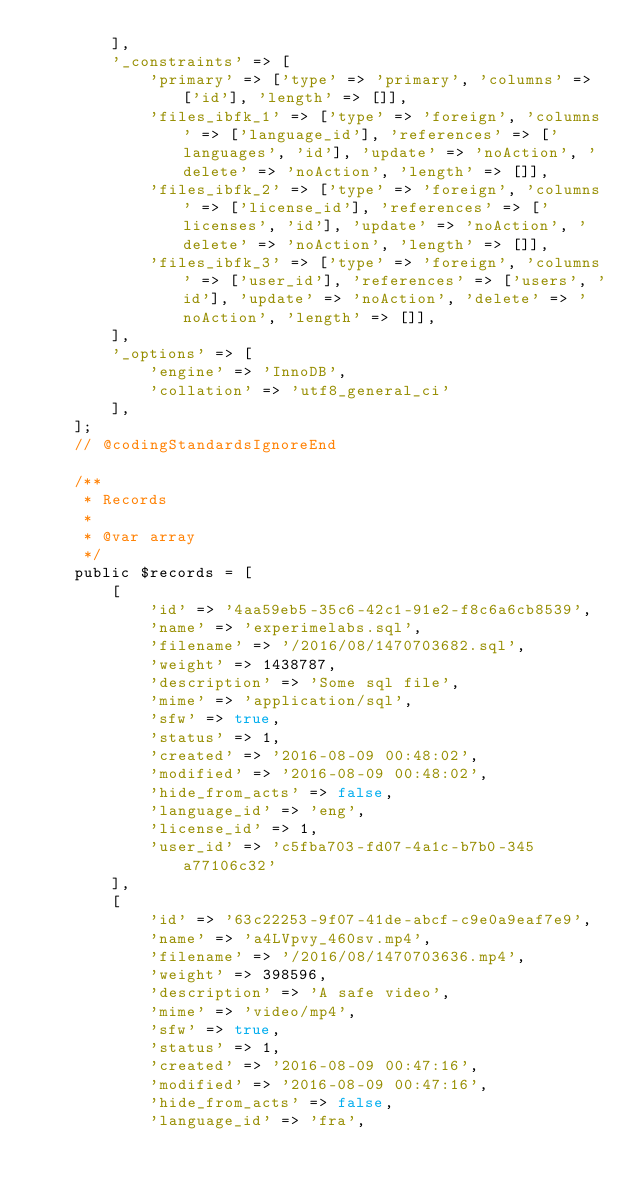Convert code to text. <code><loc_0><loc_0><loc_500><loc_500><_PHP_>        ],
        '_constraints' => [
            'primary' => ['type' => 'primary', 'columns' => ['id'], 'length' => []],
            'files_ibfk_1' => ['type' => 'foreign', 'columns' => ['language_id'], 'references' => ['languages', 'id'], 'update' => 'noAction', 'delete' => 'noAction', 'length' => []],
            'files_ibfk_2' => ['type' => 'foreign', 'columns' => ['license_id'], 'references' => ['licenses', 'id'], 'update' => 'noAction', 'delete' => 'noAction', 'length' => []],
            'files_ibfk_3' => ['type' => 'foreign', 'columns' => ['user_id'], 'references' => ['users', 'id'], 'update' => 'noAction', 'delete' => 'noAction', 'length' => []],
        ],
        '_options' => [
            'engine' => 'InnoDB',
            'collation' => 'utf8_general_ci'
        ],
    ];
    // @codingStandardsIgnoreEnd

    /**
     * Records
     *
     * @var array
     */
    public $records = [
        [
            'id' => '4aa59eb5-35c6-42c1-91e2-f8c6a6cb8539',
            'name' => 'experimelabs.sql',
            'filename' => '/2016/08/1470703682.sql',
            'weight' => 1438787,
            'description' => 'Some sql file',
            'mime' => 'application/sql',
            'sfw' => true,
            'status' => 1,
            'created' => '2016-08-09 00:48:02',
            'modified' => '2016-08-09 00:48:02',
            'hide_from_acts' => false,
            'language_id' => 'eng',
            'license_id' => 1,
            'user_id' => 'c5fba703-fd07-4a1c-b7b0-345a77106c32'
        ],
        [
            'id' => '63c22253-9f07-41de-abcf-c9e0a9eaf7e9',
            'name' => 'a4LVpvy_460sv.mp4',
            'filename' => '/2016/08/1470703636.mp4',
            'weight' => 398596,
            'description' => 'A safe video',
            'mime' => 'video/mp4',
            'sfw' => true,
            'status' => 1,
            'created' => '2016-08-09 00:47:16',
            'modified' => '2016-08-09 00:47:16',
            'hide_from_acts' => false,
            'language_id' => 'fra',</code> 